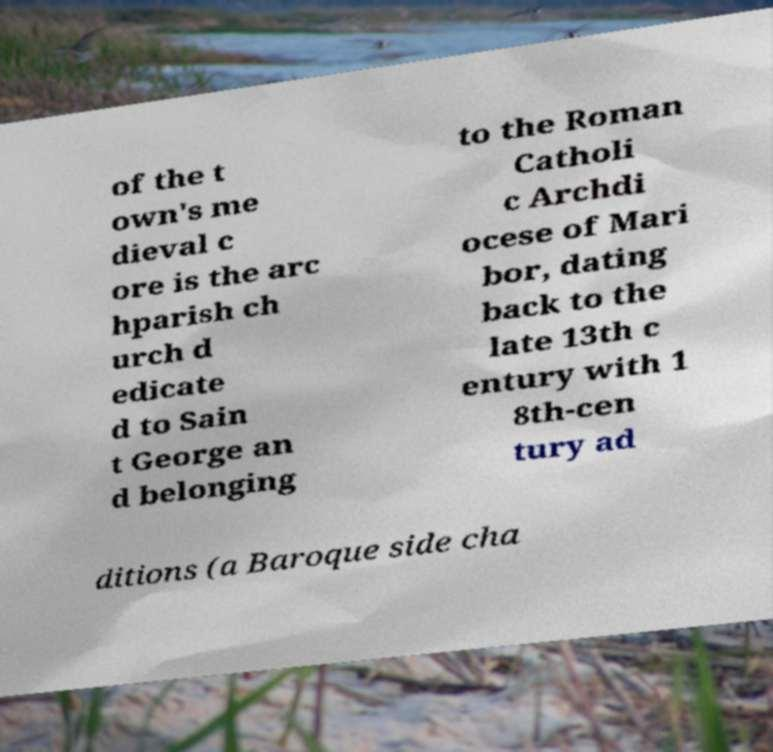For documentation purposes, I need the text within this image transcribed. Could you provide that? of the t own's me dieval c ore is the arc hparish ch urch d edicate d to Sain t George an d belonging to the Roman Catholi c Archdi ocese of Mari bor, dating back to the late 13th c entury with 1 8th-cen tury ad ditions (a Baroque side cha 